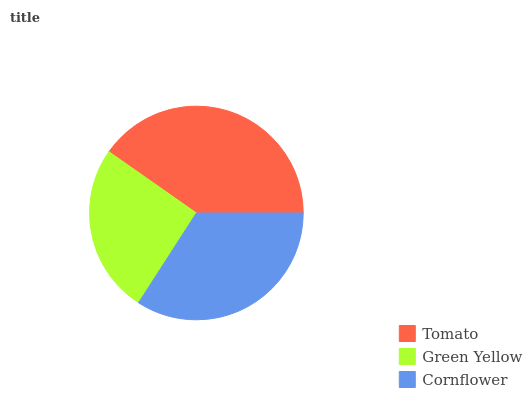Is Green Yellow the minimum?
Answer yes or no. Yes. Is Tomato the maximum?
Answer yes or no. Yes. Is Cornflower the minimum?
Answer yes or no. No. Is Cornflower the maximum?
Answer yes or no. No. Is Cornflower greater than Green Yellow?
Answer yes or no. Yes. Is Green Yellow less than Cornflower?
Answer yes or no. Yes. Is Green Yellow greater than Cornflower?
Answer yes or no. No. Is Cornflower less than Green Yellow?
Answer yes or no. No. Is Cornflower the high median?
Answer yes or no. Yes. Is Cornflower the low median?
Answer yes or no. Yes. Is Tomato the high median?
Answer yes or no. No. Is Tomato the low median?
Answer yes or no. No. 